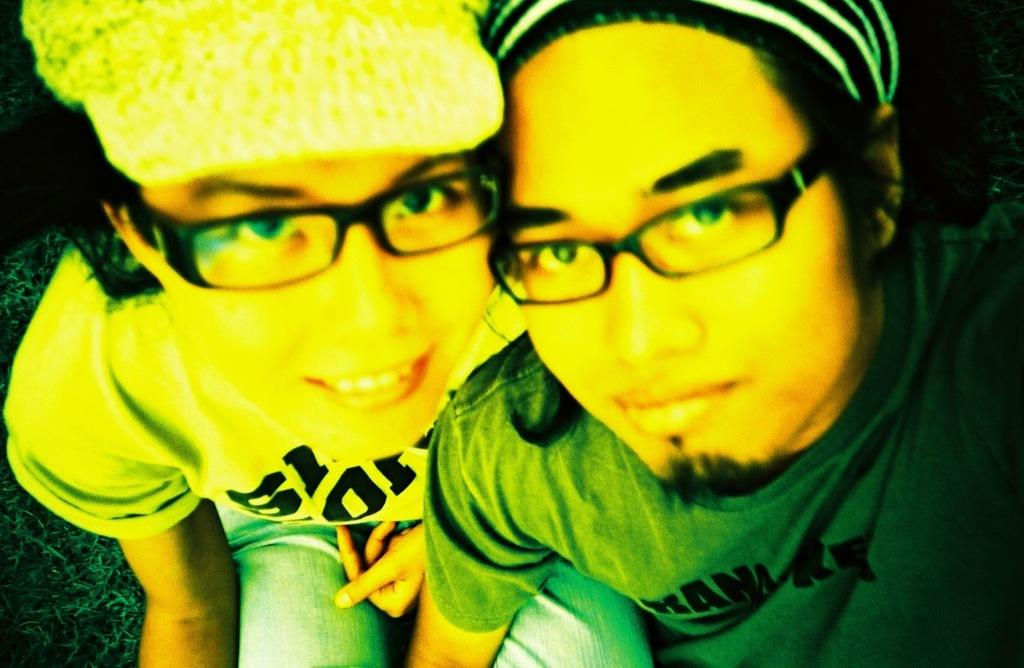What is the girl doing in the image? The girl is sitting on the sofa in the image. What can be observed about the girl's appearance? The girl is wearing spectacles, a t-shirt, trousers, and a cap. Who else is present in the image? There is a man sitting on the right side in the image. What is the man wearing? The man is wearing a green color t-shirt. What type of stamp can be seen on the girl's forehead in the image? There is no stamp visible on the girl's forehead in the image. Is there a prison visible in the background of the image? There is no prison present in the image; it features a girl sitting on a sofa and a man sitting on the right side. 